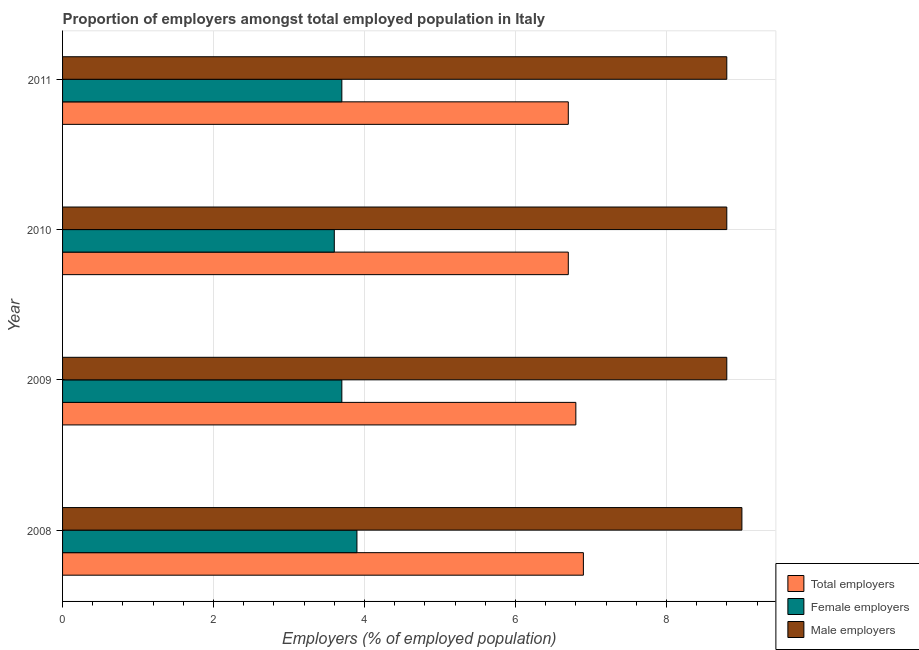How many groups of bars are there?
Your answer should be very brief. 4. Are the number of bars on each tick of the Y-axis equal?
Keep it short and to the point. Yes. How many bars are there on the 4th tick from the top?
Make the answer very short. 3. What is the percentage of male employers in 2010?
Ensure brevity in your answer.  8.8. Across all years, what is the maximum percentage of female employers?
Provide a short and direct response. 3.9. Across all years, what is the minimum percentage of female employers?
Keep it short and to the point. 3.6. In which year was the percentage of total employers minimum?
Provide a succinct answer. 2010. What is the total percentage of female employers in the graph?
Ensure brevity in your answer.  14.9. What is the difference between the percentage of male employers in 2011 and the percentage of total employers in 2009?
Make the answer very short. 2. What is the average percentage of female employers per year?
Make the answer very short. 3.73. In the year 2010, what is the difference between the percentage of total employers and percentage of male employers?
Offer a terse response. -2.1. Is the percentage of male employers in 2010 less than that in 2011?
Ensure brevity in your answer.  No. What is the difference between the highest and the second highest percentage of total employers?
Provide a succinct answer. 0.1. In how many years, is the percentage of female employers greater than the average percentage of female employers taken over all years?
Offer a very short reply. 1. Is the sum of the percentage of total employers in 2008 and 2010 greater than the maximum percentage of male employers across all years?
Ensure brevity in your answer.  Yes. What does the 2nd bar from the top in 2008 represents?
Make the answer very short. Female employers. What does the 3rd bar from the bottom in 2011 represents?
Give a very brief answer. Male employers. Is it the case that in every year, the sum of the percentage of total employers and percentage of female employers is greater than the percentage of male employers?
Offer a terse response. Yes. How many years are there in the graph?
Offer a terse response. 4. Does the graph contain any zero values?
Provide a succinct answer. No. Does the graph contain grids?
Make the answer very short. Yes. Where does the legend appear in the graph?
Keep it short and to the point. Bottom right. How many legend labels are there?
Your answer should be very brief. 3. What is the title of the graph?
Offer a very short reply. Proportion of employers amongst total employed population in Italy. Does "Czech Republic" appear as one of the legend labels in the graph?
Your answer should be very brief. No. What is the label or title of the X-axis?
Your response must be concise. Employers (% of employed population). What is the Employers (% of employed population) of Total employers in 2008?
Give a very brief answer. 6.9. What is the Employers (% of employed population) in Female employers in 2008?
Your response must be concise. 3.9. What is the Employers (% of employed population) of Total employers in 2009?
Offer a terse response. 6.8. What is the Employers (% of employed population) in Female employers in 2009?
Offer a very short reply. 3.7. What is the Employers (% of employed population) in Male employers in 2009?
Ensure brevity in your answer.  8.8. What is the Employers (% of employed population) of Total employers in 2010?
Provide a succinct answer. 6.7. What is the Employers (% of employed population) of Female employers in 2010?
Offer a very short reply. 3.6. What is the Employers (% of employed population) in Male employers in 2010?
Your answer should be compact. 8.8. What is the Employers (% of employed population) in Total employers in 2011?
Provide a succinct answer. 6.7. What is the Employers (% of employed population) of Female employers in 2011?
Offer a very short reply. 3.7. What is the Employers (% of employed population) in Male employers in 2011?
Provide a succinct answer. 8.8. Across all years, what is the maximum Employers (% of employed population) in Total employers?
Ensure brevity in your answer.  6.9. Across all years, what is the maximum Employers (% of employed population) of Female employers?
Your response must be concise. 3.9. Across all years, what is the maximum Employers (% of employed population) of Male employers?
Your response must be concise. 9. Across all years, what is the minimum Employers (% of employed population) of Total employers?
Your answer should be compact. 6.7. Across all years, what is the minimum Employers (% of employed population) in Female employers?
Provide a short and direct response. 3.6. Across all years, what is the minimum Employers (% of employed population) in Male employers?
Ensure brevity in your answer.  8.8. What is the total Employers (% of employed population) of Total employers in the graph?
Give a very brief answer. 27.1. What is the total Employers (% of employed population) in Female employers in the graph?
Provide a succinct answer. 14.9. What is the total Employers (% of employed population) of Male employers in the graph?
Offer a terse response. 35.4. What is the difference between the Employers (% of employed population) of Female employers in 2008 and that in 2010?
Give a very brief answer. 0.3. What is the difference between the Employers (% of employed population) of Female employers in 2008 and that in 2011?
Your response must be concise. 0.2. What is the difference between the Employers (% of employed population) in Total employers in 2009 and that in 2010?
Your response must be concise. 0.1. What is the difference between the Employers (% of employed population) of Female employers in 2009 and that in 2010?
Ensure brevity in your answer.  0.1. What is the difference between the Employers (% of employed population) of Male employers in 2009 and that in 2010?
Ensure brevity in your answer.  0. What is the difference between the Employers (% of employed population) of Female employers in 2009 and that in 2011?
Your response must be concise. 0. What is the difference between the Employers (% of employed population) in Male employers in 2009 and that in 2011?
Provide a succinct answer. 0. What is the difference between the Employers (% of employed population) in Female employers in 2010 and that in 2011?
Your answer should be very brief. -0.1. What is the difference between the Employers (% of employed population) in Female employers in 2008 and the Employers (% of employed population) in Male employers in 2010?
Make the answer very short. -4.9. What is the difference between the Employers (% of employed population) of Female employers in 2008 and the Employers (% of employed population) of Male employers in 2011?
Offer a very short reply. -4.9. What is the difference between the Employers (% of employed population) in Total employers in 2009 and the Employers (% of employed population) in Female employers in 2010?
Offer a terse response. 3.2. What is the difference between the Employers (% of employed population) in Total employers in 2009 and the Employers (% of employed population) in Male employers in 2011?
Provide a short and direct response. -2. What is the difference between the Employers (% of employed population) of Total employers in 2010 and the Employers (% of employed population) of Female employers in 2011?
Provide a succinct answer. 3. What is the difference between the Employers (% of employed population) of Total employers in 2010 and the Employers (% of employed population) of Male employers in 2011?
Make the answer very short. -2.1. What is the difference between the Employers (% of employed population) of Female employers in 2010 and the Employers (% of employed population) of Male employers in 2011?
Your answer should be very brief. -5.2. What is the average Employers (% of employed population) in Total employers per year?
Give a very brief answer. 6.78. What is the average Employers (% of employed population) in Female employers per year?
Ensure brevity in your answer.  3.73. What is the average Employers (% of employed population) in Male employers per year?
Make the answer very short. 8.85. In the year 2009, what is the difference between the Employers (% of employed population) of Total employers and Employers (% of employed population) of Male employers?
Keep it short and to the point. -2. In the year 2010, what is the difference between the Employers (% of employed population) of Total employers and Employers (% of employed population) of Male employers?
Your answer should be compact. -2.1. In the year 2011, what is the difference between the Employers (% of employed population) of Total employers and Employers (% of employed population) of Female employers?
Keep it short and to the point. 3. In the year 2011, what is the difference between the Employers (% of employed population) of Female employers and Employers (% of employed population) of Male employers?
Offer a very short reply. -5.1. What is the ratio of the Employers (% of employed population) of Total employers in 2008 to that in 2009?
Give a very brief answer. 1.01. What is the ratio of the Employers (% of employed population) in Female employers in 2008 to that in 2009?
Ensure brevity in your answer.  1.05. What is the ratio of the Employers (% of employed population) in Male employers in 2008 to that in 2009?
Your answer should be very brief. 1.02. What is the ratio of the Employers (% of employed population) in Total employers in 2008 to that in 2010?
Provide a succinct answer. 1.03. What is the ratio of the Employers (% of employed population) of Male employers in 2008 to that in 2010?
Give a very brief answer. 1.02. What is the ratio of the Employers (% of employed population) in Total employers in 2008 to that in 2011?
Offer a very short reply. 1.03. What is the ratio of the Employers (% of employed population) of Female employers in 2008 to that in 2011?
Ensure brevity in your answer.  1.05. What is the ratio of the Employers (% of employed population) in Male employers in 2008 to that in 2011?
Give a very brief answer. 1.02. What is the ratio of the Employers (% of employed population) in Total employers in 2009 to that in 2010?
Give a very brief answer. 1.01. What is the ratio of the Employers (% of employed population) in Female employers in 2009 to that in 2010?
Offer a very short reply. 1.03. What is the ratio of the Employers (% of employed population) in Total employers in 2009 to that in 2011?
Your answer should be compact. 1.01. What is the ratio of the Employers (% of employed population) in Male employers in 2009 to that in 2011?
Your response must be concise. 1. What is the ratio of the Employers (% of employed population) in Total employers in 2010 to that in 2011?
Provide a succinct answer. 1. What is the difference between the highest and the second highest Employers (% of employed population) in Female employers?
Offer a terse response. 0.2. What is the difference between the highest and the second highest Employers (% of employed population) in Male employers?
Your answer should be very brief. 0.2. What is the difference between the highest and the lowest Employers (% of employed population) of Total employers?
Ensure brevity in your answer.  0.2. What is the difference between the highest and the lowest Employers (% of employed population) in Female employers?
Your answer should be very brief. 0.3. 